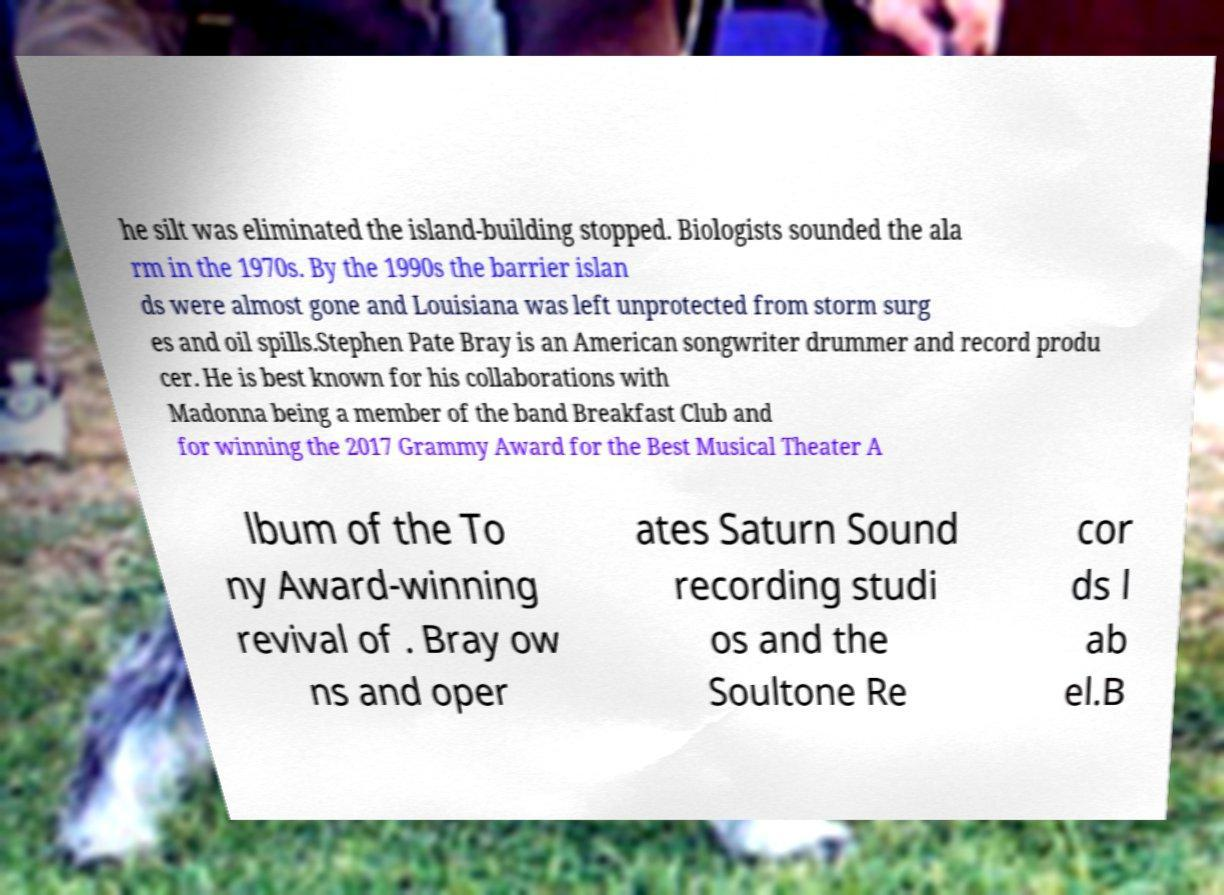Could you extract and type out the text from this image? he silt was eliminated the island-building stopped. Biologists sounded the ala rm in the 1970s. By the 1990s the barrier islan ds were almost gone and Louisiana was left unprotected from storm surg es and oil spills.Stephen Pate Bray is an American songwriter drummer and record produ cer. He is best known for his collaborations with Madonna being a member of the band Breakfast Club and for winning the 2017 Grammy Award for the Best Musical Theater A lbum of the To ny Award-winning revival of . Bray ow ns and oper ates Saturn Sound recording studi os and the Soultone Re cor ds l ab el.B 